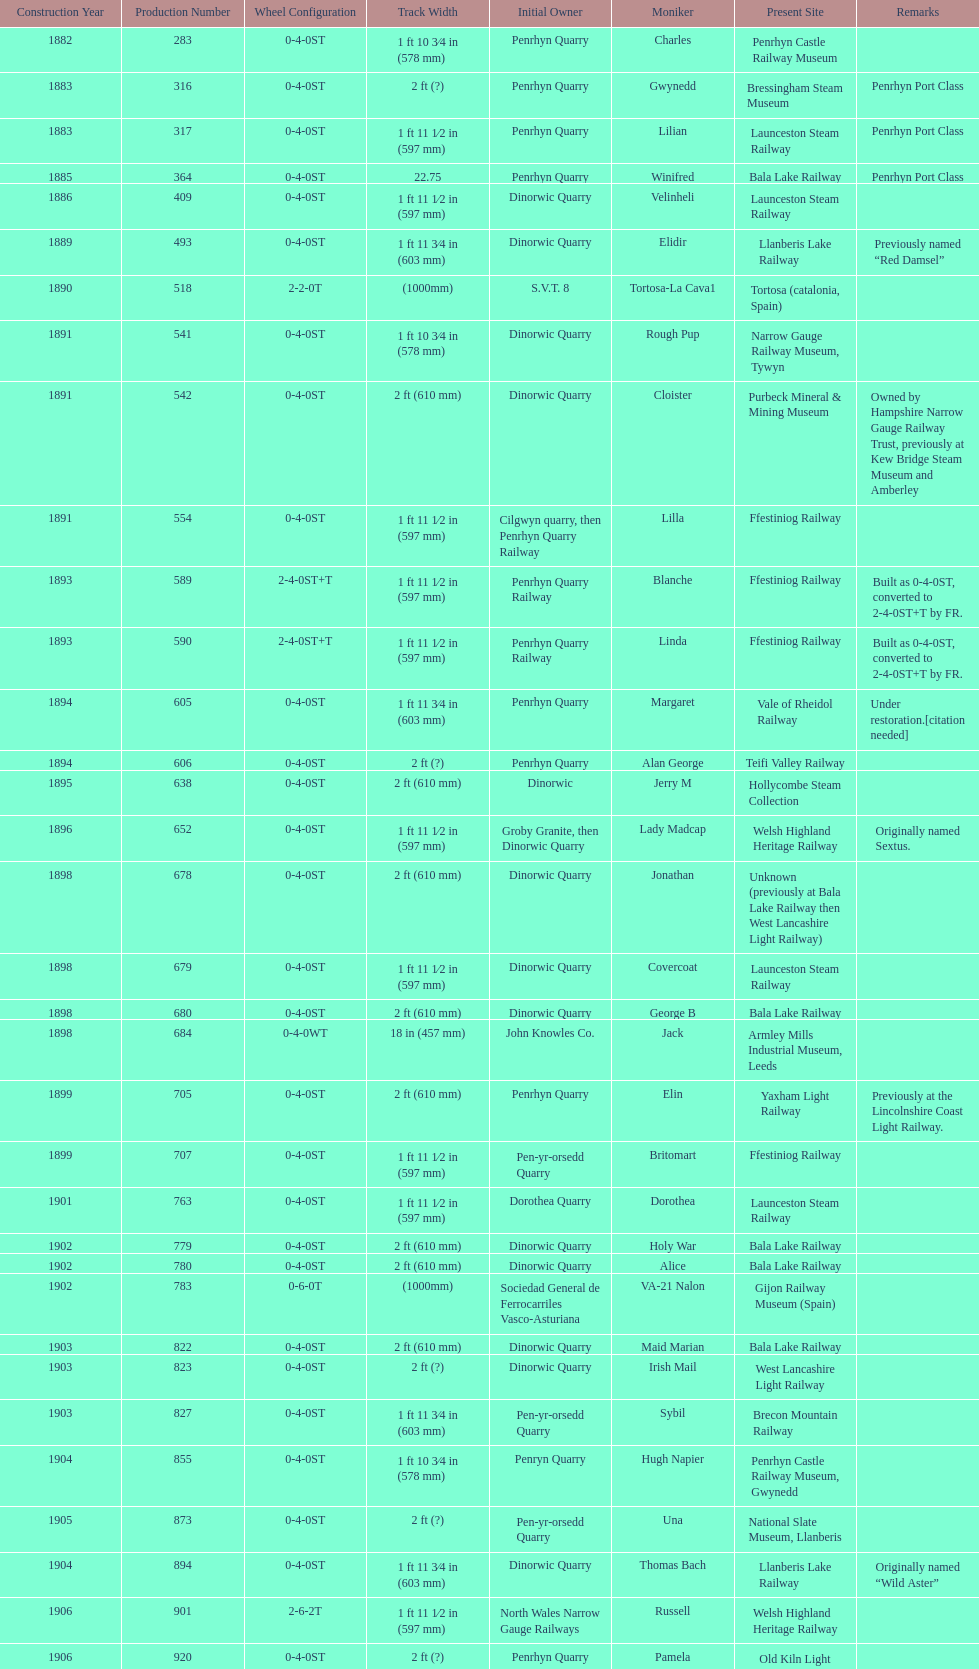In which year was the peak production of steam locomotives achieved? 1898. 